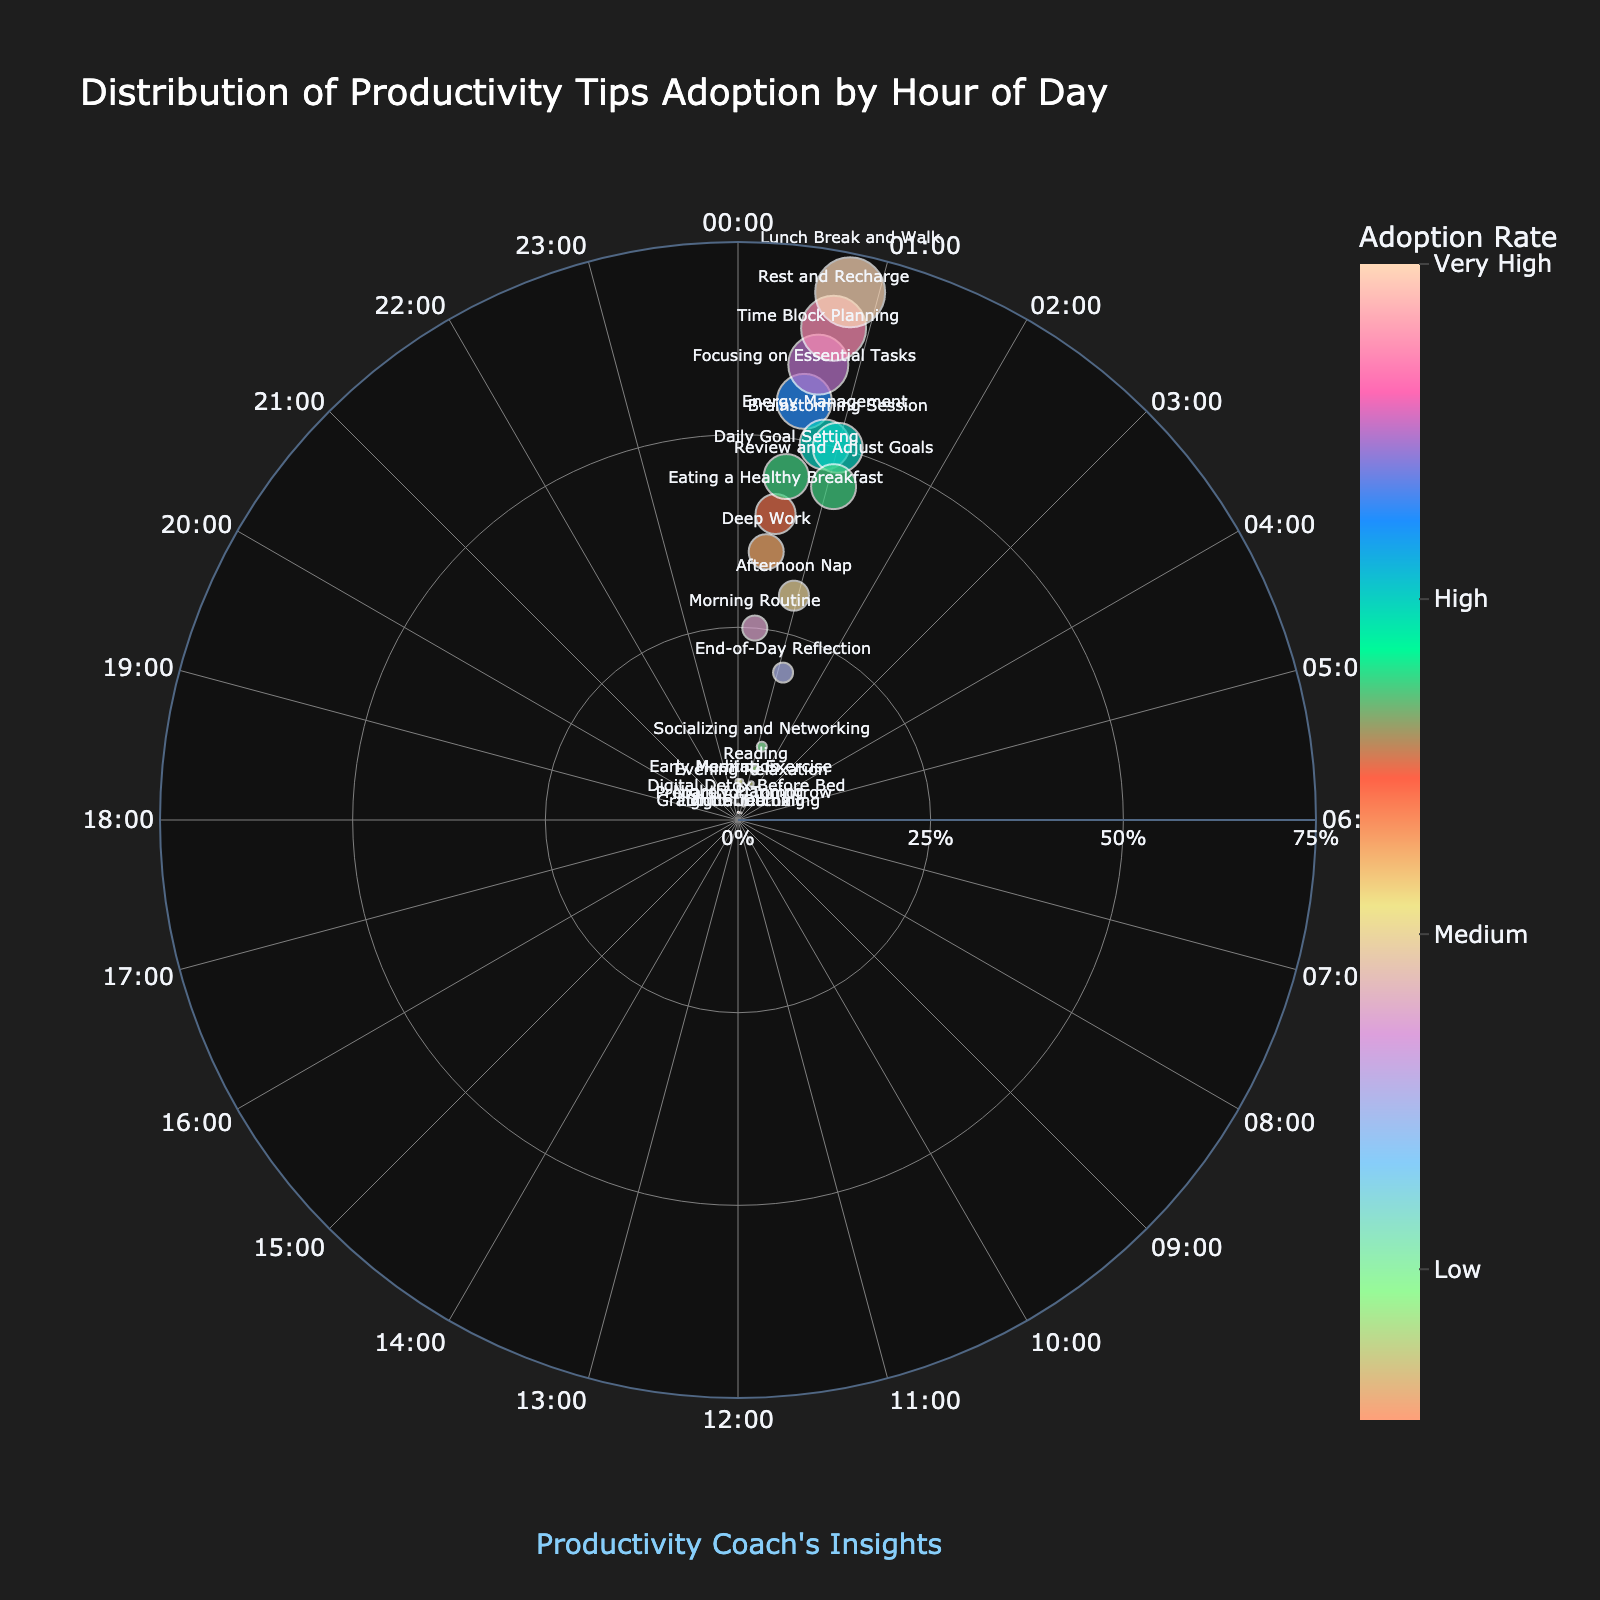What's the highest adoption rate shown in the plot? Look at the radial axis to find the highest value. The top adoption rate is 70%, for "Lunch Break and Walk" at hour 12.
Answer: 70% Which productivity tip has the lowest adoption rate and at what hour? Find the smallest marker on the plot and check its associated text. "Digital Detox" at hour 2, "Gratitude Journaling" at hour 3, and "Light Stretching" at hour 23 all have an adoption rate of 1%.
Answer: "Digital Detox" at hour 2, "Gratitude Journaling" at hour 3, "Light Stretching" at hour 23 How many tips have an adoption rate above 50%? Count markers with adoption rates higher than 50%. There are three: "Time Block Planning" at hour 10 (60%), "Rest and Recharge" at hour 11 (65%), and "Lunch Break and Walk" at hour 12 (70%).
Answer: 3 At what hours are the adoption rates highest for morning and afternoon routines respectively? Morning: Find the highest adoption rate between 0-12 hours. Afternoon: Find the highest rate between 12-24 hours. Morning is 70% at hour 12 ("Lunch Break and Walk"); afternoon is 50% at hour 13 ("Energy Management").
Answer: Morning: hour 12, Afternoon: hour 13 Which tip has a higher adoption rate, "Daily Goal Setting" or "Brainstorming Session"? Locate the markers for "Daily Goal Setting" (45% at hour 8) and "Brainstorming Session" (50% at hour 15) and compare their adoption rates. "Brainstorming Session" has a higher rate than "Daily Goal Setting".
Answer: "Brainstorming Session" What is the combined adoption rate for "Morning Routine" and "Eating a Healthy Breakfast"? Add the adoption rates for "Morning Routine" (25% at hour 5) and "Eating a Healthy Breakfast" (40% at hour 7). Combined rate is 25% + 40%.
Answer: 65% Which hour has the most tips with an adoption rate above 45%? Identify which hours have multiple tips above 45%. Hours 8 (45%), 9 (55%), 10 (60%), 11 (65%), 12 (70%), 13 (50%), 15 (50%), 16 (45%), all have at least one tip above 45%, but only hour 12 and 13 have tips over 45%.
Answer: Hour 12 How does the adoption rate for "Time Block Planning" compare to "Review and Adjust Goals"? "Time Block Planning" is at hour 10 with 60% adoption, while "Review and Adjust Goals" is at hour 16 with 45%. "Time Block Planning" has a higher rate than "Review and Adjust Goals".
Answer: "Time Block Planning" has a higher rate What is the range of adoption rates shown in the chart? The range is the difference between the highest and lowest adoption rates. Highest is 70% ("Lunch Break and Walk") and the lowest is 1% ("Digital Detox", "Gratitude Journaling", "Light Stretching"). The range is 70% - 1%.
Answer: 69% Which productivity tips are adopted most frequently in the afternoon (12:00 - 18:00)? Identify tips with high adoption rates between hour 12 and 18. "Lunch Break and Walk" at hour 12 (70%), "Energy Management" at hour 13 (50%), "Brainstorming Session" at hour 15 (50%).
Answer: "Lunch Break and Walk", "Energy Management", "Brainstorming Session" 